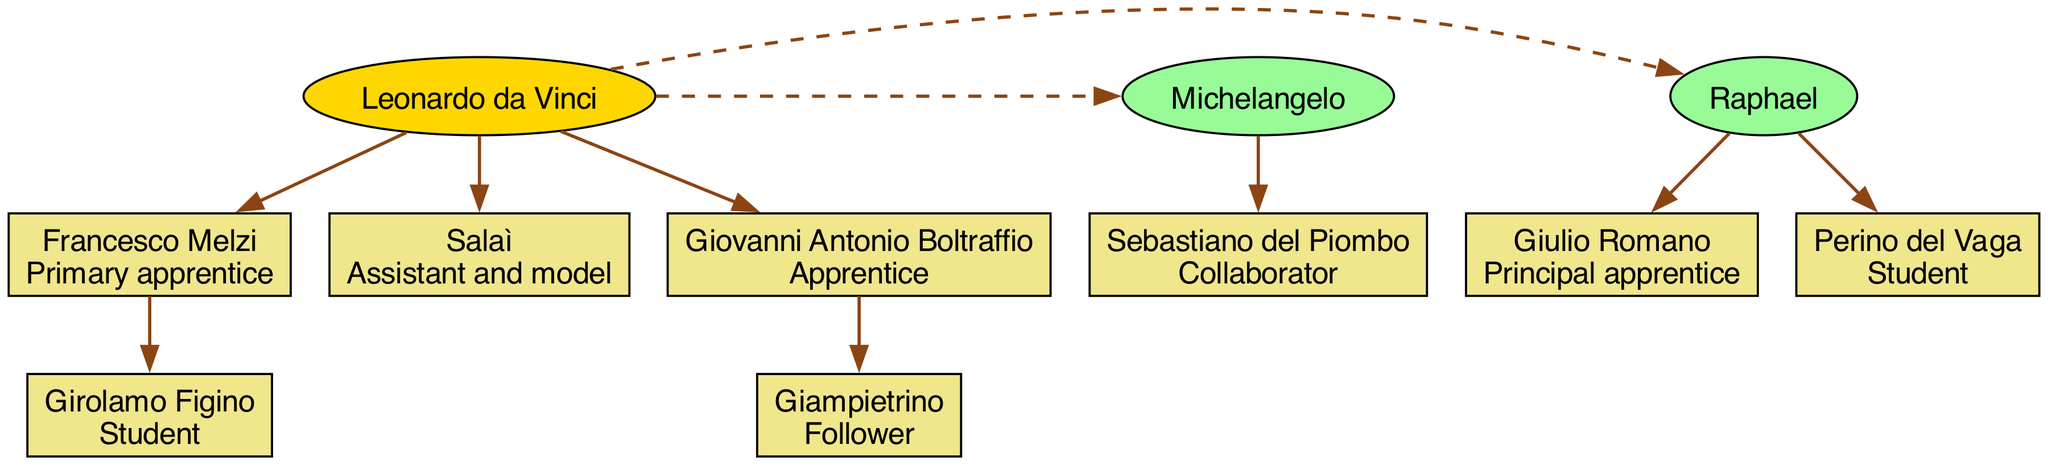What is the role of Francesco Melzi? In the diagram, Francesco Melzi is labeled as the "Primary apprentice" under Leonardo da Vinci. This indicates his position and relationship to Leonardo within the lineage of artists.
Answer: Primary apprentice How many children does Leonardo da Vinci have? By examining the diagram, it shows that Leonardo da Vinci has three children listed under him: Francesco Melzi, Salaì, and Giovanni Antonio Boltraffio. Therefore, the total count is three.
Answer: 3 Who is the principal apprentice of Raphael? In the diagram, Giulio Romano is specifically labeled as the "Principal apprentice" of Raphael. This establishes a direct relationship and role between the two artists.
Answer: Giulio Romano Which artist collaborated with Michelangelo? According to the diagram, Sebastiano del Piombo is noted as the "Collaborator" with Michelangelo, indicating a cooperative relationship in their artistic endeavors.
Answer: Sebastiano del Piombo Name one student of Giovanni Antonio Boltraffio. The diagram shows that Giampietrino is listed as a "Follower" under Giovanni Antonio Boltraffio, indicating that he studied or was influenced by Boltraffio.
Answer: Giampietrino How are the relationships between Leonardo da Vinci and his siblings characterized? The diagram illustrates a dashed line from Leonardo da Vinci to his siblings, Michelangelo and Raphael, suggesting a relationship characterized by artistic kinship while remaining separate. This implies a familial but distinct artistic lineage among them.
Answer: Dashed line signifies kinship Who is the assistant and model of Leonardo da Vinci? The diagram presents Salaì as the "Assistant and model" to Leonardo da Vinci, clearly defining his role in relation to Leonardo's work and legacy.
Answer: Salaì How many total apprentices are connected to Raphael? Analyzing the diagram reveals that Raphael has two apprentices listed: Giulio Romano and Perino del Vaga. Thus, the total number of apprentices associated with Raphael is two.
Answer: 2 What common role do Girolamo Figino and Perino del Vaga share in the diagram? Both Girolamo Figino and Perino del Vaga are classified as students under their respective masters, indicating that they are both in an apprentice-like role. This reflects their learning and development in the arts.
Answer: Students Which artist has a direct teaching lineage to Girolamo Figino? The diagram shows that Girolamo Figino is a student under Francesco Melzi, who is in turn an apprentice of Leonardo da Vinci. This establishes a clear teaching lineage from Leonardo to Melzi, and then to Figino.
Answer: Francesco Melzi 